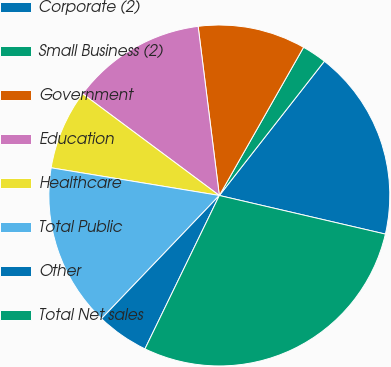Convert chart. <chart><loc_0><loc_0><loc_500><loc_500><pie_chart><fcel>Corporate (2)<fcel>Small Business (2)<fcel>Government<fcel>Education<fcel>Healthcare<fcel>Total Public<fcel>Other<fcel>Total Net sales<nl><fcel>18.07%<fcel>2.34%<fcel>10.21%<fcel>12.83%<fcel>7.59%<fcel>15.45%<fcel>4.96%<fcel>28.55%<nl></chart> 